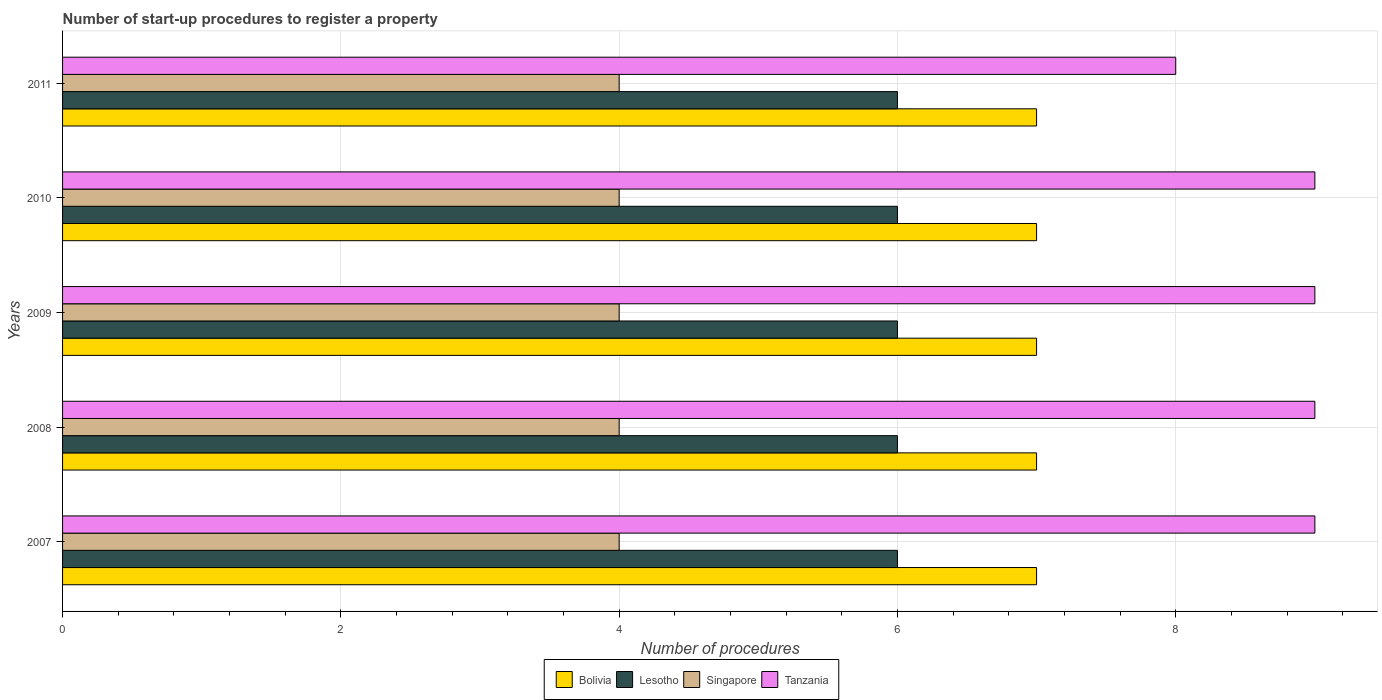How many groups of bars are there?
Give a very brief answer. 5. Are the number of bars per tick equal to the number of legend labels?
Your answer should be compact. Yes. In how many cases, is the number of bars for a given year not equal to the number of legend labels?
Provide a succinct answer. 0. What is the number of procedures required to register a property in Bolivia in 2007?
Give a very brief answer. 7. Across all years, what is the minimum number of procedures required to register a property in Bolivia?
Provide a succinct answer. 7. In which year was the number of procedures required to register a property in Lesotho maximum?
Your answer should be very brief. 2007. What is the total number of procedures required to register a property in Singapore in the graph?
Offer a terse response. 20. What is the difference between the number of procedures required to register a property in Lesotho in 2008 and that in 2011?
Provide a short and direct response. 0. What is the difference between the number of procedures required to register a property in Lesotho in 2011 and the number of procedures required to register a property in Tanzania in 2008?
Make the answer very short. -3. In the year 2008, what is the difference between the number of procedures required to register a property in Lesotho and number of procedures required to register a property in Singapore?
Offer a very short reply. 2. In how many years, is the number of procedures required to register a property in Lesotho greater than 0.8 ?
Your answer should be very brief. 5. Is the number of procedures required to register a property in Singapore in 2007 less than that in 2009?
Offer a very short reply. No. What does the 2nd bar from the top in 2008 represents?
Give a very brief answer. Singapore. What does the 3rd bar from the bottom in 2010 represents?
Provide a short and direct response. Singapore. What is the difference between two consecutive major ticks on the X-axis?
Offer a terse response. 2. Does the graph contain any zero values?
Offer a terse response. No. Does the graph contain grids?
Make the answer very short. Yes. Where does the legend appear in the graph?
Ensure brevity in your answer.  Bottom center. How many legend labels are there?
Give a very brief answer. 4. How are the legend labels stacked?
Make the answer very short. Horizontal. What is the title of the graph?
Your response must be concise. Number of start-up procedures to register a property. Does "Central Europe" appear as one of the legend labels in the graph?
Keep it short and to the point. No. What is the label or title of the X-axis?
Make the answer very short. Number of procedures. What is the Number of procedures in Tanzania in 2007?
Your answer should be very brief. 9. What is the Number of procedures in Singapore in 2008?
Offer a terse response. 4. What is the Number of procedures in Singapore in 2009?
Offer a very short reply. 4. What is the Number of procedures of Tanzania in 2009?
Offer a very short reply. 9. What is the Number of procedures of Bolivia in 2010?
Make the answer very short. 7. What is the Number of procedures of Singapore in 2010?
Ensure brevity in your answer.  4. What is the Number of procedures of Tanzania in 2010?
Make the answer very short. 9. What is the Number of procedures in Bolivia in 2011?
Your answer should be compact. 7. What is the Number of procedures of Singapore in 2011?
Give a very brief answer. 4. Across all years, what is the minimum Number of procedures of Bolivia?
Your answer should be very brief. 7. Across all years, what is the minimum Number of procedures of Lesotho?
Offer a very short reply. 6. What is the total Number of procedures of Lesotho in the graph?
Your answer should be very brief. 30. What is the total Number of procedures in Singapore in the graph?
Your response must be concise. 20. What is the total Number of procedures of Tanzania in the graph?
Make the answer very short. 44. What is the difference between the Number of procedures in Bolivia in 2007 and that in 2008?
Offer a terse response. 0. What is the difference between the Number of procedures of Lesotho in 2007 and that in 2008?
Provide a short and direct response. 0. What is the difference between the Number of procedures in Tanzania in 2007 and that in 2008?
Provide a short and direct response. 0. What is the difference between the Number of procedures in Lesotho in 2007 and that in 2009?
Your answer should be compact. 0. What is the difference between the Number of procedures of Lesotho in 2007 and that in 2010?
Provide a short and direct response. 0. What is the difference between the Number of procedures in Singapore in 2007 and that in 2010?
Keep it short and to the point. 0. What is the difference between the Number of procedures in Lesotho in 2007 and that in 2011?
Offer a terse response. 0. What is the difference between the Number of procedures of Tanzania in 2007 and that in 2011?
Your answer should be very brief. 1. What is the difference between the Number of procedures in Lesotho in 2008 and that in 2009?
Your answer should be very brief. 0. What is the difference between the Number of procedures in Tanzania in 2008 and that in 2009?
Provide a short and direct response. 0. What is the difference between the Number of procedures of Bolivia in 2008 and that in 2010?
Provide a short and direct response. 0. What is the difference between the Number of procedures in Singapore in 2008 and that in 2010?
Your response must be concise. 0. What is the difference between the Number of procedures of Bolivia in 2008 and that in 2011?
Provide a short and direct response. 0. What is the difference between the Number of procedures of Lesotho in 2008 and that in 2011?
Provide a succinct answer. 0. What is the difference between the Number of procedures of Singapore in 2008 and that in 2011?
Your response must be concise. 0. What is the difference between the Number of procedures in Tanzania in 2008 and that in 2011?
Keep it short and to the point. 1. What is the difference between the Number of procedures of Lesotho in 2009 and that in 2010?
Offer a terse response. 0. What is the difference between the Number of procedures of Tanzania in 2009 and that in 2010?
Offer a very short reply. 0. What is the difference between the Number of procedures in Bolivia in 2009 and that in 2011?
Provide a short and direct response. 0. What is the difference between the Number of procedures in Lesotho in 2007 and the Number of procedures in Tanzania in 2008?
Your answer should be very brief. -3. What is the difference between the Number of procedures in Bolivia in 2007 and the Number of procedures in Tanzania in 2009?
Offer a terse response. -2. What is the difference between the Number of procedures in Lesotho in 2007 and the Number of procedures in Singapore in 2009?
Your response must be concise. 2. What is the difference between the Number of procedures of Lesotho in 2007 and the Number of procedures of Tanzania in 2009?
Provide a short and direct response. -3. What is the difference between the Number of procedures in Singapore in 2007 and the Number of procedures in Tanzania in 2009?
Your answer should be compact. -5. What is the difference between the Number of procedures in Bolivia in 2007 and the Number of procedures in Lesotho in 2010?
Provide a succinct answer. 1. What is the difference between the Number of procedures of Bolivia in 2007 and the Number of procedures of Tanzania in 2010?
Provide a succinct answer. -2. What is the difference between the Number of procedures of Bolivia in 2007 and the Number of procedures of Lesotho in 2011?
Your response must be concise. 1. What is the difference between the Number of procedures of Bolivia in 2007 and the Number of procedures of Tanzania in 2011?
Offer a terse response. -1. What is the difference between the Number of procedures in Lesotho in 2007 and the Number of procedures in Singapore in 2011?
Your answer should be very brief. 2. What is the difference between the Number of procedures in Lesotho in 2007 and the Number of procedures in Tanzania in 2011?
Offer a terse response. -2. What is the difference between the Number of procedures of Bolivia in 2008 and the Number of procedures of Singapore in 2009?
Give a very brief answer. 3. What is the difference between the Number of procedures in Bolivia in 2008 and the Number of procedures in Tanzania in 2009?
Provide a short and direct response. -2. What is the difference between the Number of procedures in Lesotho in 2008 and the Number of procedures in Tanzania in 2009?
Offer a very short reply. -3. What is the difference between the Number of procedures of Singapore in 2008 and the Number of procedures of Tanzania in 2009?
Make the answer very short. -5. What is the difference between the Number of procedures in Bolivia in 2008 and the Number of procedures in Singapore in 2010?
Your response must be concise. 3. What is the difference between the Number of procedures in Bolivia in 2008 and the Number of procedures in Tanzania in 2010?
Provide a succinct answer. -2. What is the difference between the Number of procedures of Lesotho in 2008 and the Number of procedures of Singapore in 2010?
Your response must be concise. 2. What is the difference between the Number of procedures in Bolivia in 2008 and the Number of procedures in Singapore in 2011?
Offer a very short reply. 3. What is the difference between the Number of procedures in Lesotho in 2008 and the Number of procedures in Singapore in 2011?
Provide a short and direct response. 2. What is the difference between the Number of procedures of Lesotho in 2008 and the Number of procedures of Tanzania in 2011?
Make the answer very short. -2. What is the difference between the Number of procedures of Bolivia in 2009 and the Number of procedures of Lesotho in 2010?
Your answer should be compact. 1. What is the difference between the Number of procedures in Bolivia in 2009 and the Number of procedures in Tanzania in 2010?
Your answer should be compact. -2. What is the difference between the Number of procedures of Lesotho in 2009 and the Number of procedures of Singapore in 2010?
Your answer should be compact. 2. What is the difference between the Number of procedures of Singapore in 2009 and the Number of procedures of Tanzania in 2010?
Offer a terse response. -5. What is the difference between the Number of procedures in Bolivia in 2009 and the Number of procedures in Lesotho in 2011?
Your response must be concise. 1. What is the difference between the Number of procedures in Bolivia in 2009 and the Number of procedures in Singapore in 2011?
Your answer should be compact. 3. What is the difference between the Number of procedures in Lesotho in 2009 and the Number of procedures in Singapore in 2011?
Make the answer very short. 2. What is the difference between the Number of procedures of Bolivia in 2010 and the Number of procedures of Tanzania in 2011?
Offer a very short reply. -1. What is the average Number of procedures of Lesotho per year?
Keep it short and to the point. 6. In the year 2007, what is the difference between the Number of procedures of Bolivia and Number of procedures of Lesotho?
Provide a succinct answer. 1. In the year 2007, what is the difference between the Number of procedures of Bolivia and Number of procedures of Singapore?
Provide a short and direct response. 3. In the year 2007, what is the difference between the Number of procedures of Bolivia and Number of procedures of Tanzania?
Provide a short and direct response. -2. In the year 2007, what is the difference between the Number of procedures in Lesotho and Number of procedures in Singapore?
Offer a very short reply. 2. In the year 2007, what is the difference between the Number of procedures in Lesotho and Number of procedures in Tanzania?
Ensure brevity in your answer.  -3. In the year 2007, what is the difference between the Number of procedures in Singapore and Number of procedures in Tanzania?
Give a very brief answer. -5. In the year 2008, what is the difference between the Number of procedures of Bolivia and Number of procedures of Singapore?
Your response must be concise. 3. In the year 2008, what is the difference between the Number of procedures in Bolivia and Number of procedures in Tanzania?
Keep it short and to the point. -2. In the year 2008, what is the difference between the Number of procedures of Lesotho and Number of procedures of Tanzania?
Your answer should be very brief. -3. In the year 2009, what is the difference between the Number of procedures in Bolivia and Number of procedures in Tanzania?
Keep it short and to the point. -2. In the year 2009, what is the difference between the Number of procedures in Lesotho and Number of procedures in Singapore?
Offer a very short reply. 2. In the year 2010, what is the difference between the Number of procedures in Singapore and Number of procedures in Tanzania?
Keep it short and to the point. -5. In the year 2011, what is the difference between the Number of procedures in Bolivia and Number of procedures in Lesotho?
Give a very brief answer. 1. In the year 2011, what is the difference between the Number of procedures of Lesotho and Number of procedures of Singapore?
Offer a very short reply. 2. What is the ratio of the Number of procedures of Singapore in 2007 to that in 2009?
Keep it short and to the point. 1. What is the ratio of the Number of procedures of Tanzania in 2007 to that in 2009?
Offer a terse response. 1. What is the ratio of the Number of procedures in Lesotho in 2007 to that in 2010?
Provide a short and direct response. 1. What is the ratio of the Number of procedures in Bolivia in 2007 to that in 2011?
Keep it short and to the point. 1. What is the ratio of the Number of procedures in Lesotho in 2007 to that in 2011?
Give a very brief answer. 1. What is the ratio of the Number of procedures in Singapore in 2007 to that in 2011?
Ensure brevity in your answer.  1. What is the ratio of the Number of procedures in Tanzania in 2007 to that in 2011?
Offer a very short reply. 1.12. What is the ratio of the Number of procedures in Tanzania in 2008 to that in 2010?
Your answer should be very brief. 1. What is the ratio of the Number of procedures of Bolivia in 2008 to that in 2011?
Your response must be concise. 1. What is the ratio of the Number of procedures of Lesotho in 2008 to that in 2011?
Offer a very short reply. 1. What is the ratio of the Number of procedures of Singapore in 2008 to that in 2011?
Provide a short and direct response. 1. What is the ratio of the Number of procedures of Tanzania in 2008 to that in 2011?
Offer a terse response. 1.12. What is the ratio of the Number of procedures of Lesotho in 2009 to that in 2010?
Ensure brevity in your answer.  1. What is the ratio of the Number of procedures of Singapore in 2009 to that in 2010?
Provide a succinct answer. 1. What is the ratio of the Number of procedures of Tanzania in 2009 to that in 2011?
Your answer should be very brief. 1.12. What is the ratio of the Number of procedures in Bolivia in 2010 to that in 2011?
Keep it short and to the point. 1. What is the ratio of the Number of procedures in Lesotho in 2010 to that in 2011?
Ensure brevity in your answer.  1. What is the ratio of the Number of procedures of Singapore in 2010 to that in 2011?
Give a very brief answer. 1. What is the difference between the highest and the second highest Number of procedures of Singapore?
Ensure brevity in your answer.  0. 